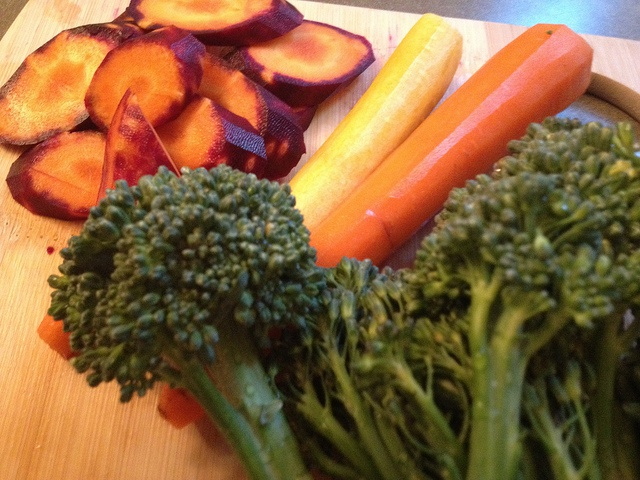Describe the objects in this image and their specific colors. I can see dining table in black, darkgreen, orange, maroon, and gray tones, broccoli in olive, black, darkgreen, and gray tones, broccoli in olive, black, darkgreen, and gray tones, carrot in olive, red, orange, salmon, and brown tones, and carrot in olive, maroon, brown, and red tones in this image. 